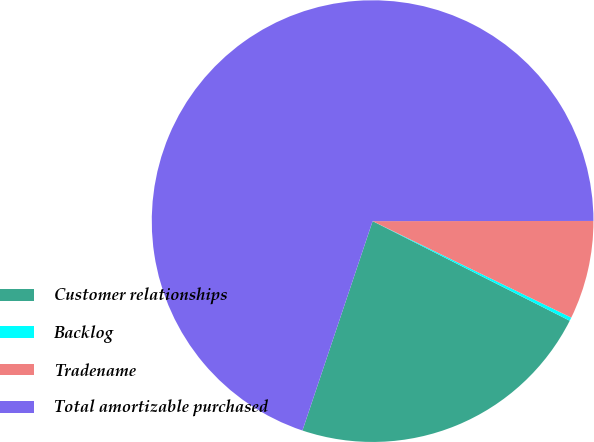<chart> <loc_0><loc_0><loc_500><loc_500><pie_chart><fcel>Customer relationships<fcel>Backlog<fcel>Tradename<fcel>Total amortizable purchased<nl><fcel>22.7%<fcel>0.25%<fcel>7.21%<fcel>69.84%<nl></chart> 